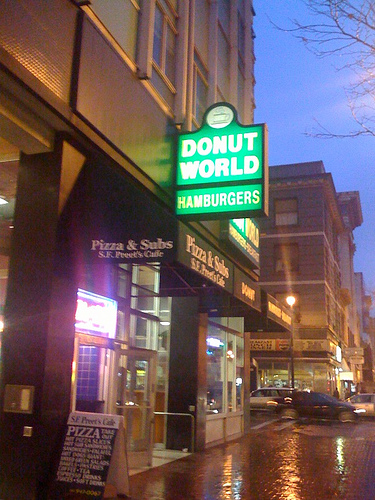<image>
Is there a sign next to the building? Yes. The sign is positioned adjacent to the building, located nearby in the same general area. Is the car under the sign? No. The car is not positioned under the sign. The vertical relationship between these objects is different. Is the lamp above the car? Yes. The lamp is positioned above the car in the vertical space, higher up in the scene. 